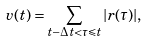<formula> <loc_0><loc_0><loc_500><loc_500>v ( t ) = \sum _ { t - \Delta t < \tau \leqslant t } | r ( \tau ) | ,</formula> 